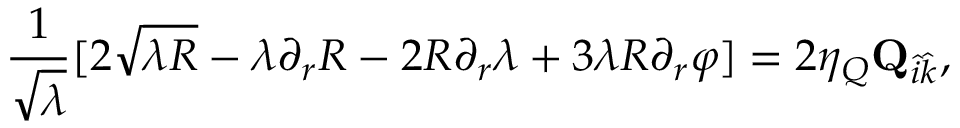<formula> <loc_0><loc_0><loc_500><loc_500>{ \frac { 1 } { \sqrt { \lambda } } } [ 2 \sqrt { \lambda R } - \lambda \partial _ { r } R - 2 R \partial _ { r } \lambda + 3 \lambda R \partial _ { r } \varphi ] = 2 \eta _ { Q } { Q } _ { \hat { i } \hat { k } } ,</formula> 